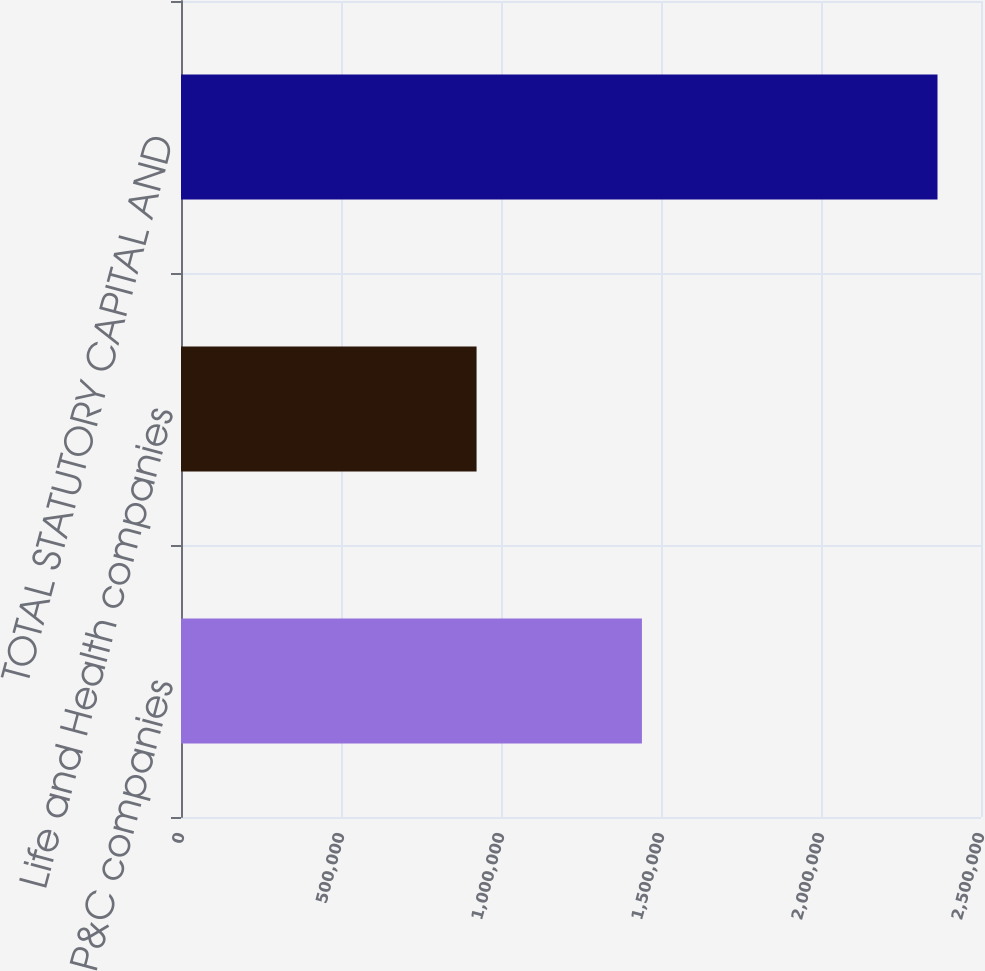Convert chart. <chart><loc_0><loc_0><loc_500><loc_500><bar_chart><fcel>P&C companies<fcel>Life and Health companies<fcel>TOTAL STATUTORY CAPITAL AND<nl><fcel>1.44039e+06<fcel>923660<fcel>2.36405e+06<nl></chart> 